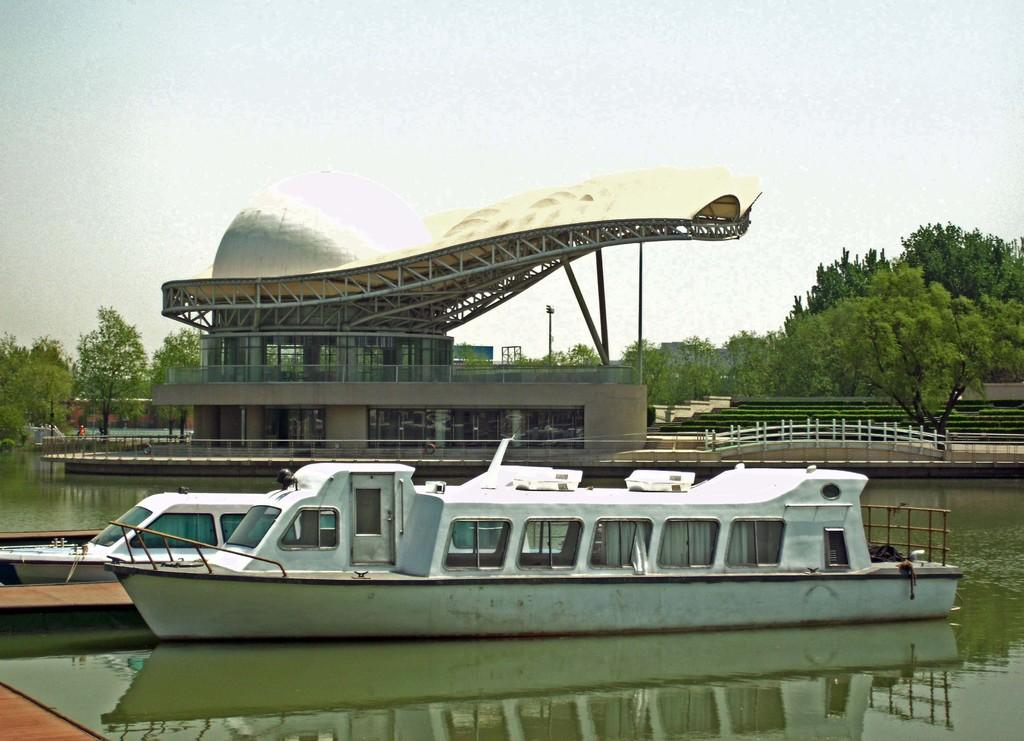What can be seen floating on the water in the image? There are two boats on the water in the image. What type of structure is present in the image? There is a building in the image. What surrounds the building? There is a fence around the building. What type of vegetation is visible in the image? There are trees visible in the image. What is visible at the top of the image? The sky is visible at the top of the image. What type of sand can be seen on the fifth boat in the image? There are no boats mentioned in the facts, and there is no mention of sand in the image. 